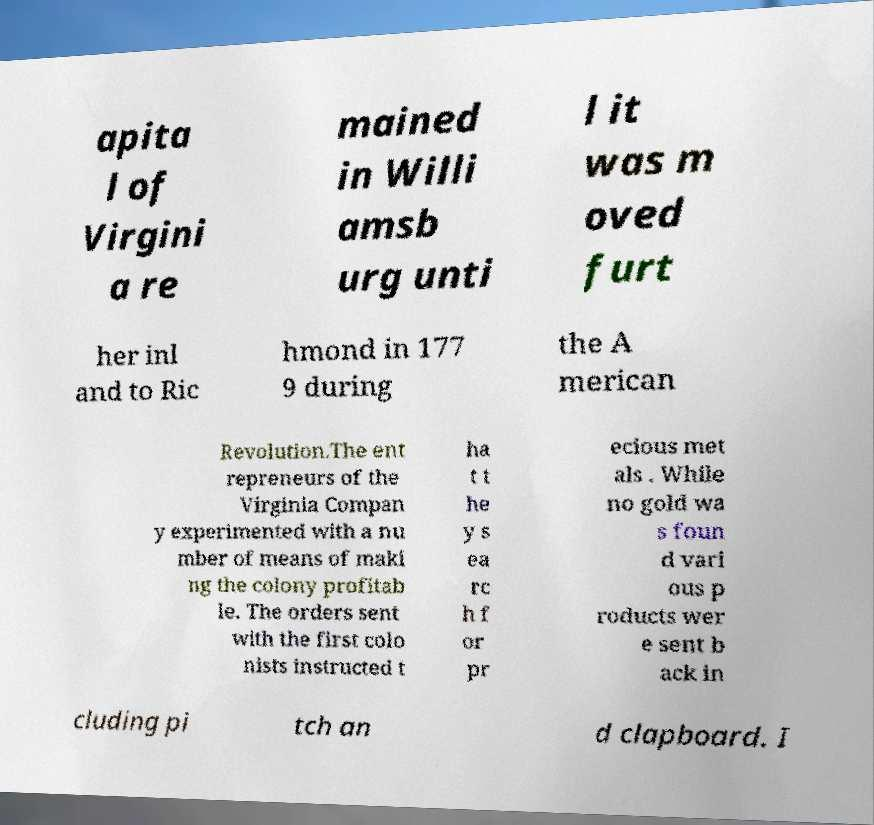Can you accurately transcribe the text from the provided image for me? apita l of Virgini a re mained in Willi amsb urg unti l it was m oved furt her inl and to Ric hmond in 177 9 during the A merican Revolution.The ent repreneurs of the Virginia Compan y experimented with a nu mber of means of maki ng the colony profitab le. The orders sent with the first colo nists instructed t ha t t he y s ea rc h f or pr ecious met als . While no gold wa s foun d vari ous p roducts wer e sent b ack in cluding pi tch an d clapboard. I 